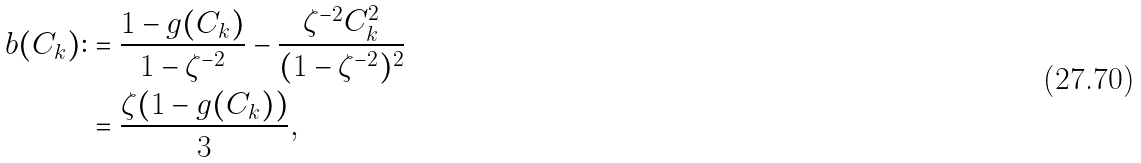Convert formula to latex. <formula><loc_0><loc_0><loc_500><loc_500>b ( C _ { k } ) \colon & = \frac { 1 - g ( C _ { k } ) } { 1 - \zeta ^ { - 2 } } - \frac { \zeta ^ { - 2 } C _ { k } ^ { 2 } } { ( 1 - \zeta ^ { - 2 } ) ^ { 2 } } \\ & = \frac { \zeta ( 1 - g ( C _ { k } ) ) } { 3 } ,</formula> 